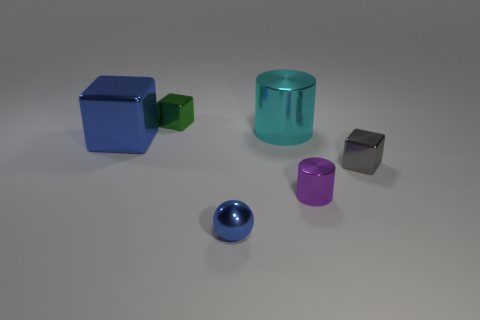Add 2 tiny cyan rubber balls. How many objects exist? 8 Subtract all gray cylinders. Subtract all cyan cubes. How many cylinders are left? 2 Subtract all cylinders. How many objects are left? 4 Add 1 big blocks. How many big blocks exist? 2 Subtract 0 red cubes. How many objects are left? 6 Subtract all large blue metal cubes. Subtract all things. How many objects are left? 4 Add 5 gray metal things. How many gray metal things are left? 6 